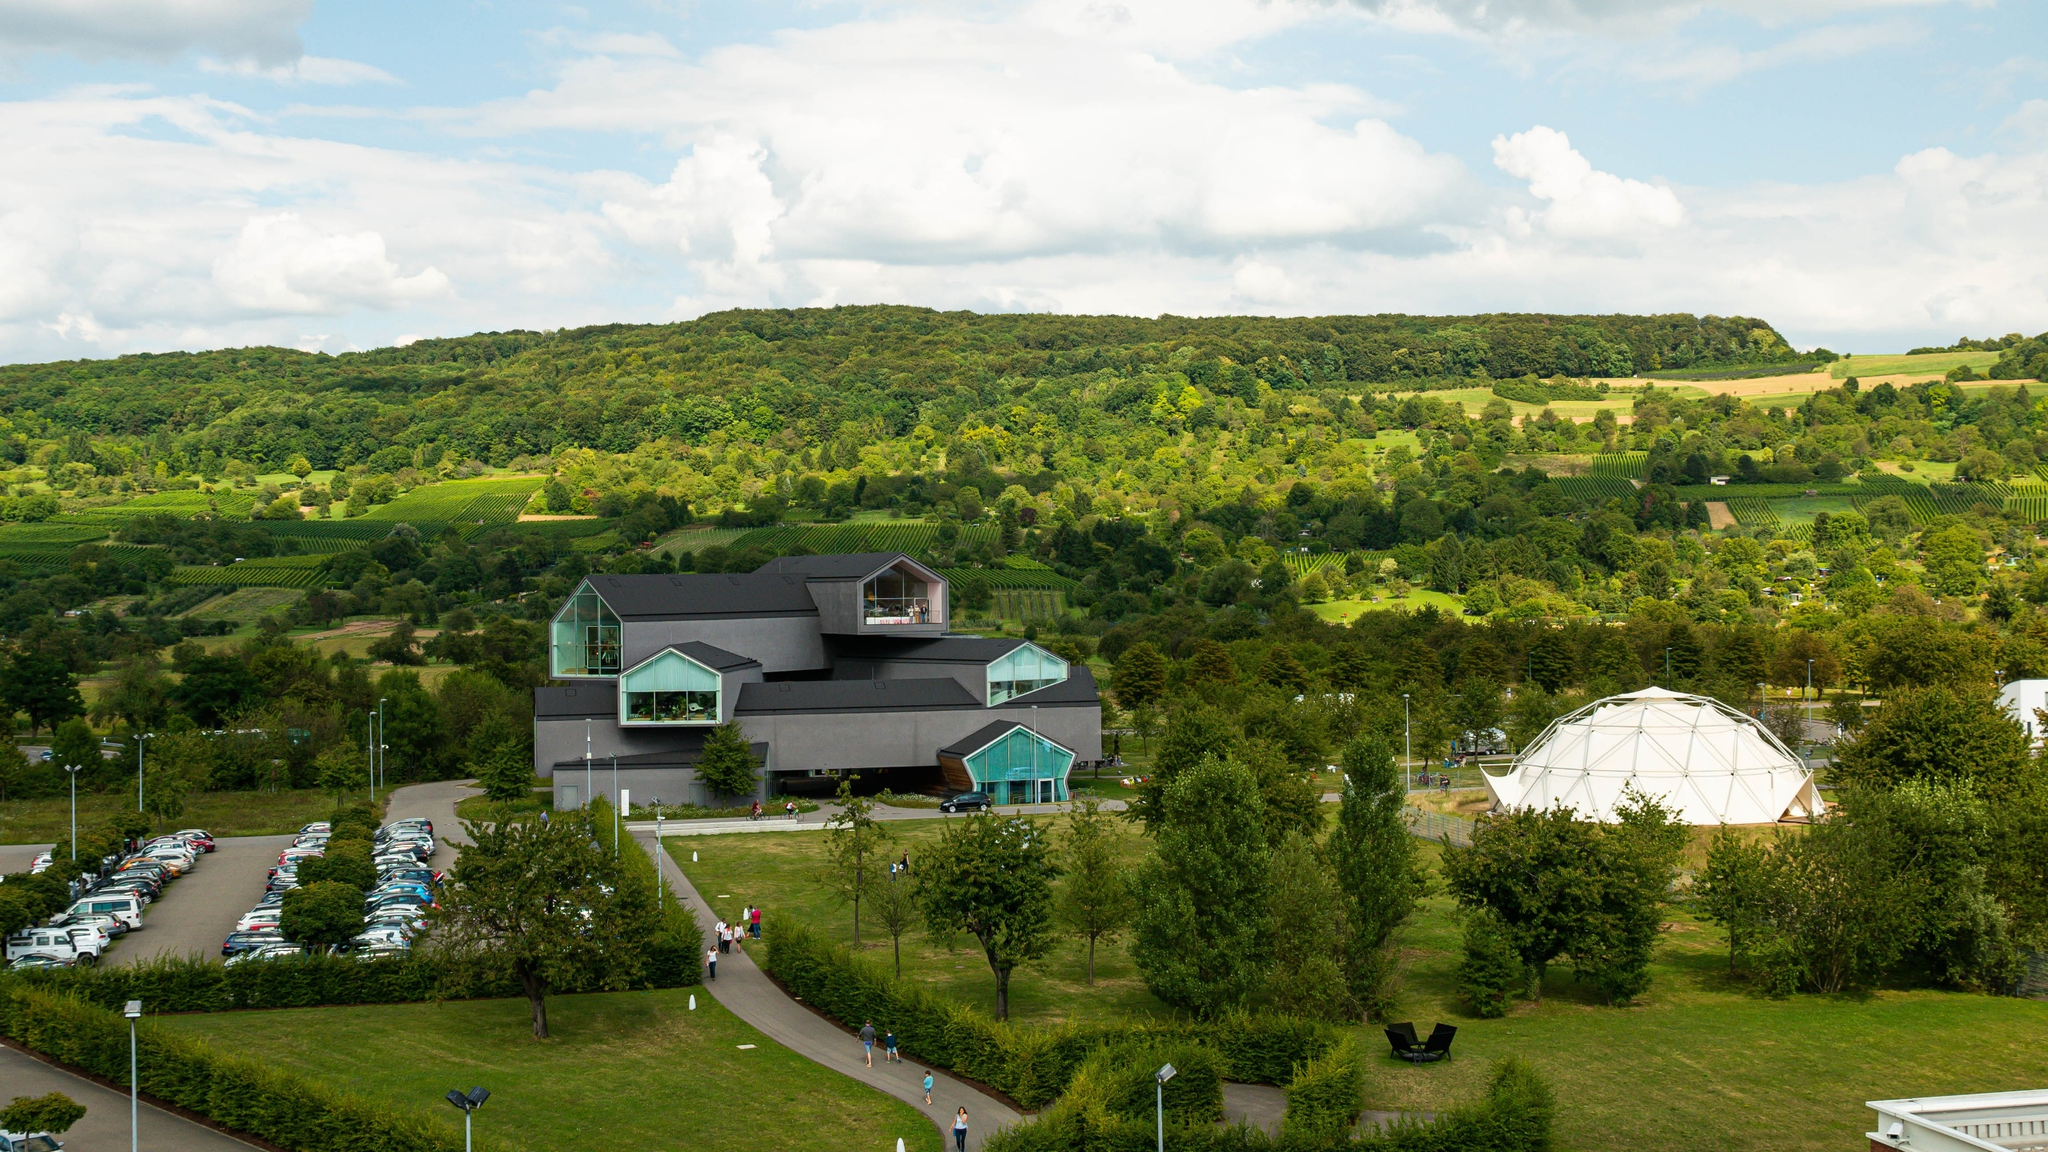What types of landscapes are visible in the background? The background of the image reveals a scenic landscape of rolling hills covered with dense forests and meticulously cultivated fields. These elements create a patchwork of various shades of green, offering a tranquil and natural setting. The hills are adorned with scattered trees and bushes, enhancing the pastoral beauty of the scene. Overall, the landscape provides a striking contrast to the contemporary design of the Vitra Design Museum. 